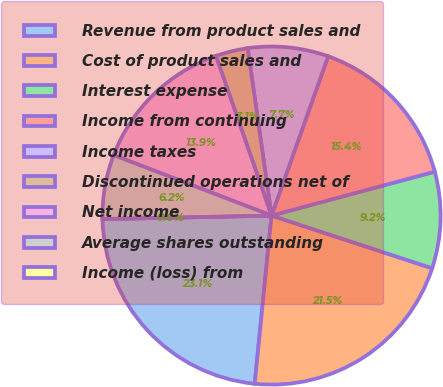Convert chart to OTSL. <chart><loc_0><loc_0><loc_500><loc_500><pie_chart><fcel>Revenue from product sales and<fcel>Cost of product sales and<fcel>Interest expense<fcel>Income from continuing<fcel>Income taxes<fcel>Discontinued operations net of<fcel>Net income<fcel>Average shares outstanding<fcel>Income (loss) from<nl><fcel>23.08%<fcel>21.54%<fcel>9.23%<fcel>15.38%<fcel>7.69%<fcel>3.08%<fcel>13.85%<fcel>6.15%<fcel>0.0%<nl></chart> 